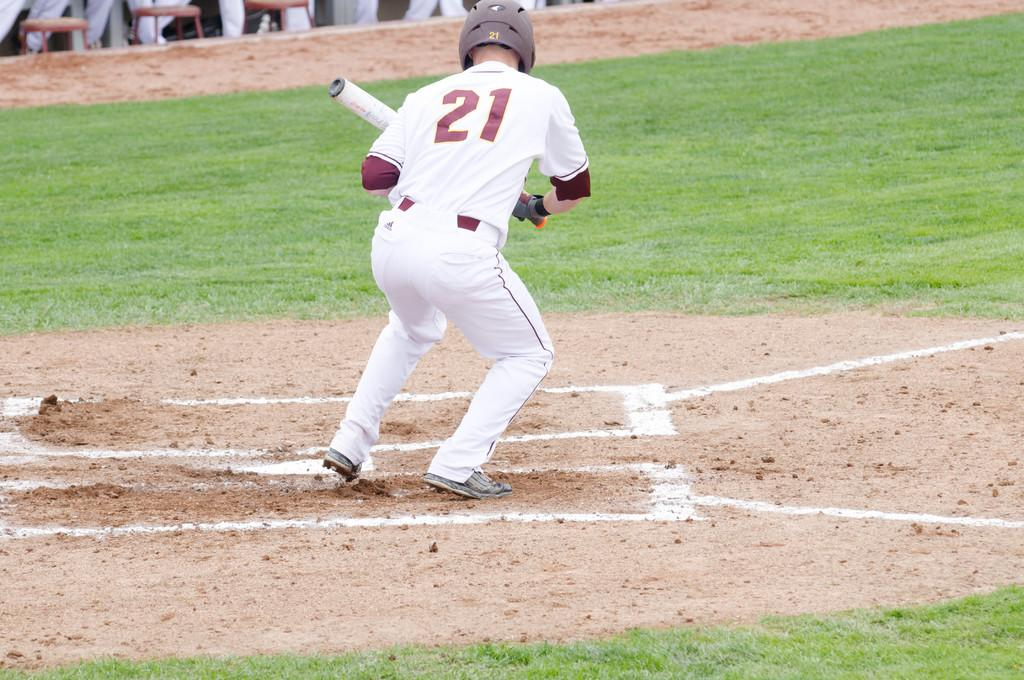<image>
Offer a succinct explanation of the picture presented. a player that has the number 21 on their jersey 